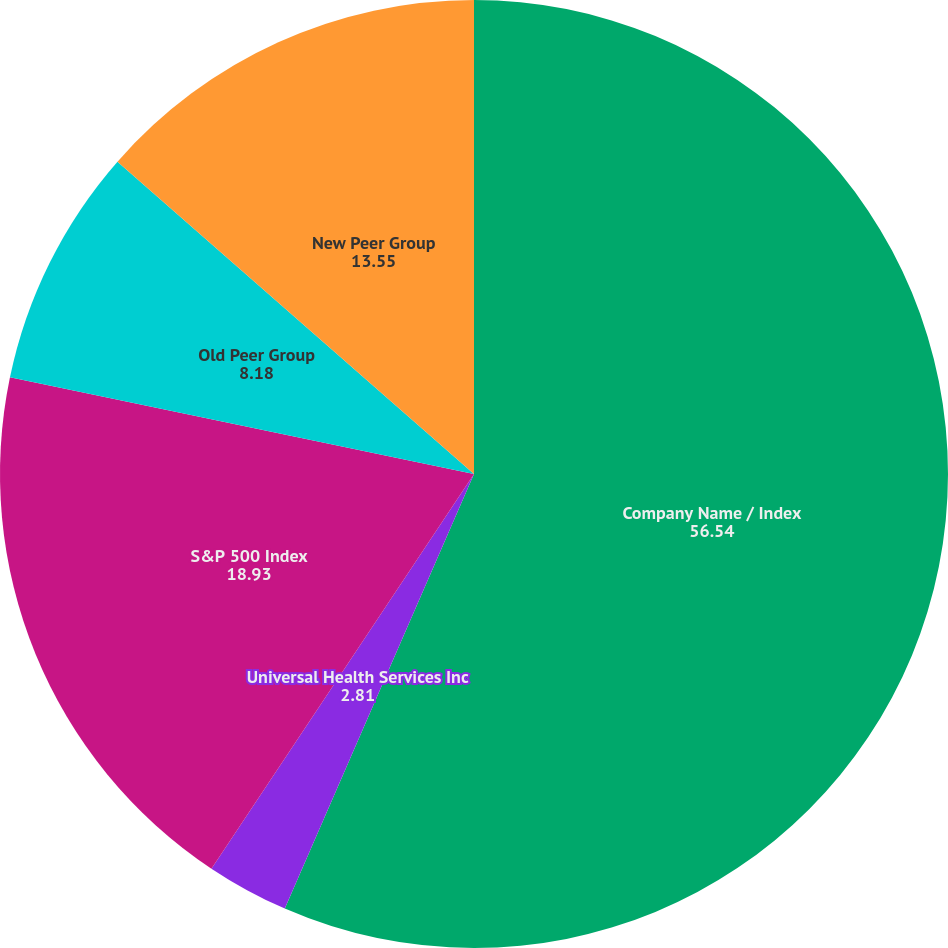Convert chart. <chart><loc_0><loc_0><loc_500><loc_500><pie_chart><fcel>Company Name / Index<fcel>Universal Health Services Inc<fcel>S&P 500 Index<fcel>Old Peer Group<fcel>New Peer Group<nl><fcel>56.54%<fcel>2.81%<fcel>18.93%<fcel>8.18%<fcel>13.55%<nl></chart> 